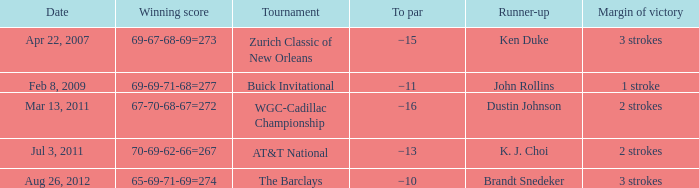What is the date that has a winning score of 67-70-68-67=272? Mar 13, 2011. 